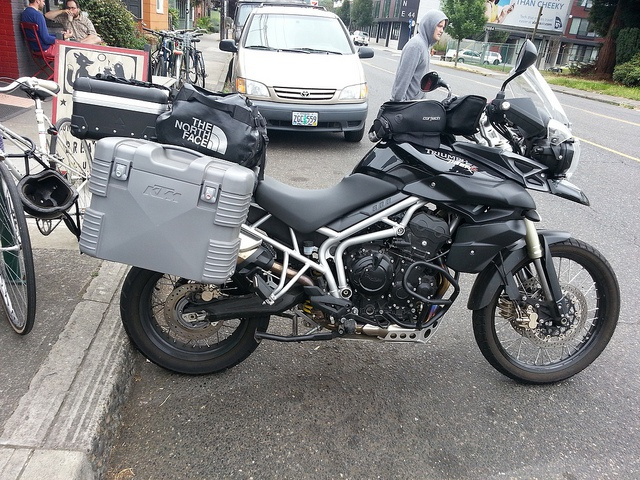Describe the objects in this image and their specific colors. I can see motorcycle in maroon, black, gray, darkgray, and lightgray tones, car in maroon, white, darkgray, gray, and black tones, bicycle in maroon, lightgray, black, gray, and darkgray tones, suitcase in maroon, white, gray, and black tones, and people in maroon, darkgray, lightgray, and gray tones in this image. 